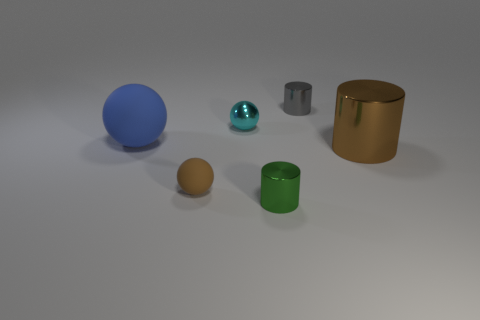Do the tiny rubber object and the big cylinder have the same color?
Your response must be concise. Yes. What material is the tiny ball behind the big matte object that is on the left side of the small shiny cylinder in front of the blue ball made of?
Your response must be concise. Metal. Does the big metallic object have the same color as the small sphere in front of the brown cylinder?
Ensure brevity in your answer.  Yes. What color is the tiny object on the right side of the metal thing in front of the tiny brown object?
Provide a short and direct response. Gray. How many blue balls are there?
Offer a terse response. 1. How many metallic objects are tiny yellow cubes or big spheres?
Provide a succinct answer. 0. How many big cylinders are the same color as the small rubber ball?
Offer a very short reply. 1. The tiny ball that is in front of the large thing that is on the right side of the big blue matte object is made of what material?
Keep it short and to the point. Rubber. How big is the blue matte sphere?
Your response must be concise. Large. What number of shiny things are the same size as the gray cylinder?
Your response must be concise. 2. 